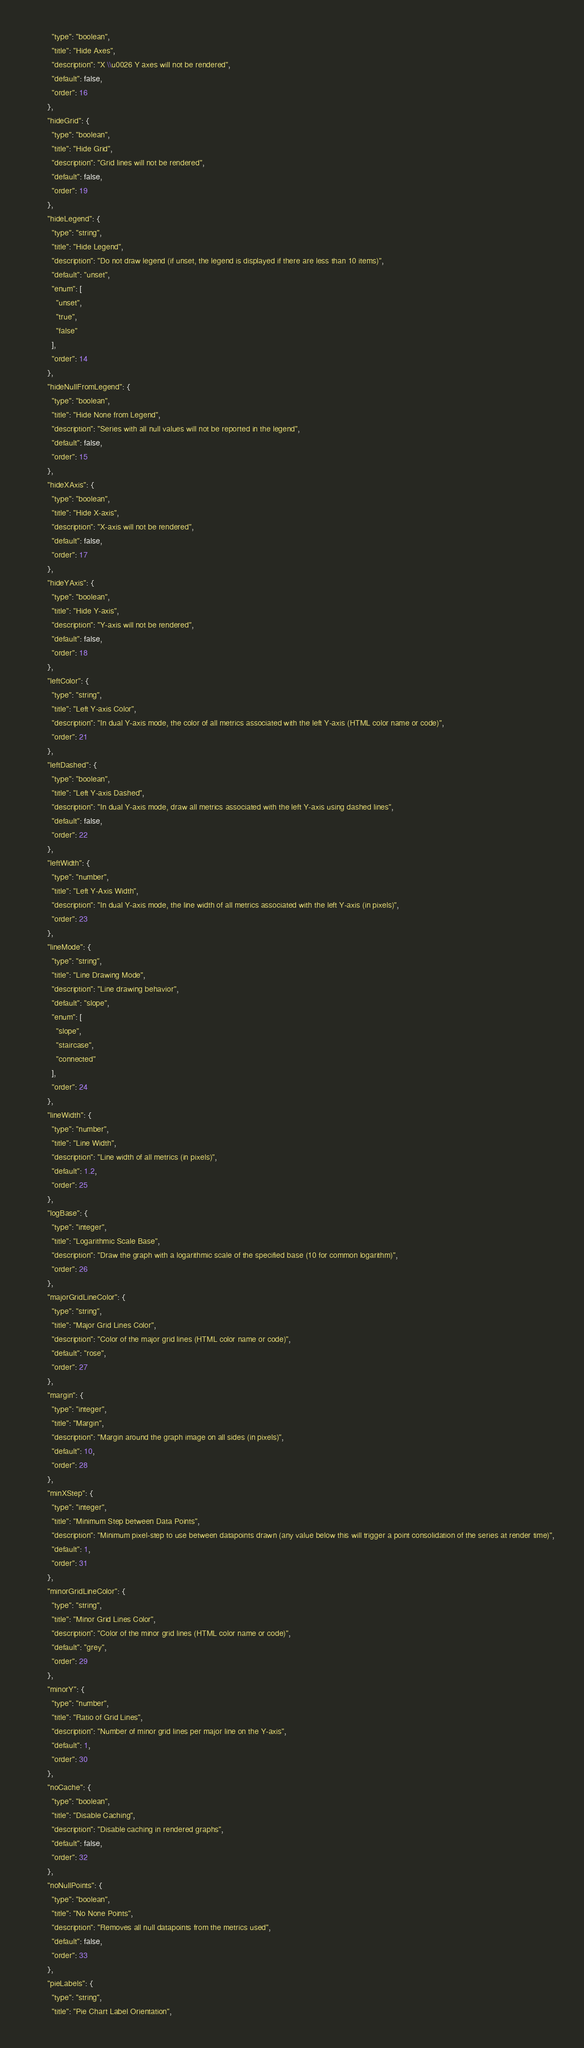Convert code to text. <code><loc_0><loc_0><loc_500><loc_500><_Python_>          "type": "boolean",
          "title": "Hide Axes",
          "description": "X \\u0026 Y axes will not be rendered",
          "default": false,
          "order": 16
        },
        "hideGrid": {
          "type": "boolean",
          "title": "Hide Grid",
          "description": "Grid lines will not be rendered",
          "default": false,
          "order": 19
        },
        "hideLegend": {
          "type": "string",
          "title": "Hide Legend",
          "description": "Do not draw legend (if unset, the legend is displayed if there are less than 10 items)",
          "default": "unset",
          "enum": [
            "unset",
            "true",
            "false"
          ],
          "order": 14
        },
        "hideNullFromLegend": {
          "type": "boolean",
          "title": "Hide None from Legend",
          "description": "Series with all null values will not be reported in the legend",
          "default": false,
          "order": 15
        },
        "hideXAxis": {
          "type": "boolean",
          "title": "Hide X-axis",
          "description": "X-axis will not be rendered",
          "default": false,
          "order": 17
        },
        "hideYAxis": {
          "type": "boolean",
          "title": "Hide Y-axis",
          "description": "Y-axis will not be rendered",
          "default": false,
          "order": 18
        },
        "leftColor": {
          "type": "string",
          "title": "Left Y-axis Color",
          "description": "In dual Y-axis mode, the color of all metrics associated with the left Y-axis (HTML color name or code)",
          "order": 21
        },
        "leftDashed": {
          "type": "boolean",
          "title": "Left Y-axis Dashed",
          "description": "In dual Y-axis mode, draw all metrics associated with the left Y-axis using dashed lines",
          "default": false,
          "order": 22
        },
        "leftWidth": {
          "type": "number",
          "title": "Left Y-Axis Width",
          "description": "In dual Y-axis mode, the line width of all metrics associated with the left Y-axis (in pixels)",
          "order": 23
        },
        "lineMode": {
          "type": "string",
          "title": "Line Drawing Mode",
          "description": "Line drawing behavior",
          "default": "slope",
          "enum": [
            "slope",
            "staircase",
            "connected"
          ],
          "order": 24
        },
        "lineWidth": {
          "type": "number",
          "title": "Line Width",
          "description": "Line width of all metrics (in pixels)",
          "default": 1.2,
          "order": 25
        },
        "logBase": {
          "type": "integer",
          "title": "Logarithmic Scale Base",
          "description": "Draw the graph with a logarithmic scale of the specified base (10 for common logarithm)",
          "order": 26
        },
        "majorGridLineColor": {
          "type": "string",
          "title": "Major Grid Lines Color",
          "description": "Color of the major grid lines (HTML color name or code)",
          "default": "rose",
          "order": 27
        },
        "margin": {
          "type": "integer",
          "title": "Margin",
          "description": "Margin around the graph image on all sides (in pixels)",
          "default": 10,
          "order": 28
        },
        "minXStep": {
          "type": "integer",
          "title": "Minimum Step between Data Points",
          "description": "Minimum pixel-step to use between datapoints drawn (any value below this will trigger a point consolidation of the series at render time)",
          "default": 1,
          "order": 31
        },
        "minorGridLineColor": {
          "type": "string",
          "title": "Minor Grid Lines Color",
          "description": "Color of the minor grid lines (HTML color name or code)",
          "default": "grey",
          "order": 29
        },
        "minorY": {
          "type": "number",
          "title": "Ratio of Grid Lines",
          "description": "Number of minor grid lines per major line on the Y-axis",
          "default": 1,
          "order": 30
        },
        "noCache": {
          "type": "boolean",
          "title": "Disable Caching",
          "description": "Disable caching in rendered graphs",
          "default": false,
          "order": 32
        },
        "noNullPoints": {
          "type": "boolean",
          "title": "No None Points",
          "description": "Removes all null datapoints from the metrics used",
          "default": false,
          "order": 33
        },
        "pieLabels": {
          "type": "string",
          "title": "Pie Chart Label Orientation",</code> 